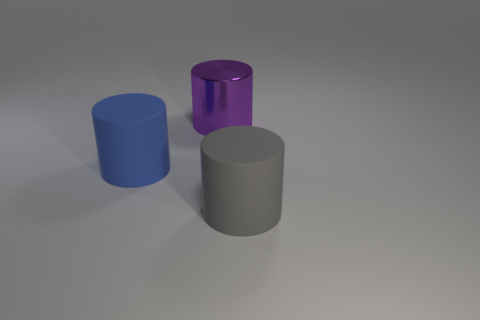Add 3 big cylinders. How many objects exist? 6 Add 3 matte cylinders. How many matte cylinders exist? 5 Subtract 1 purple cylinders. How many objects are left? 2 Subtract all big yellow matte cylinders. Subtract all big things. How many objects are left? 0 Add 1 large things. How many large things are left? 4 